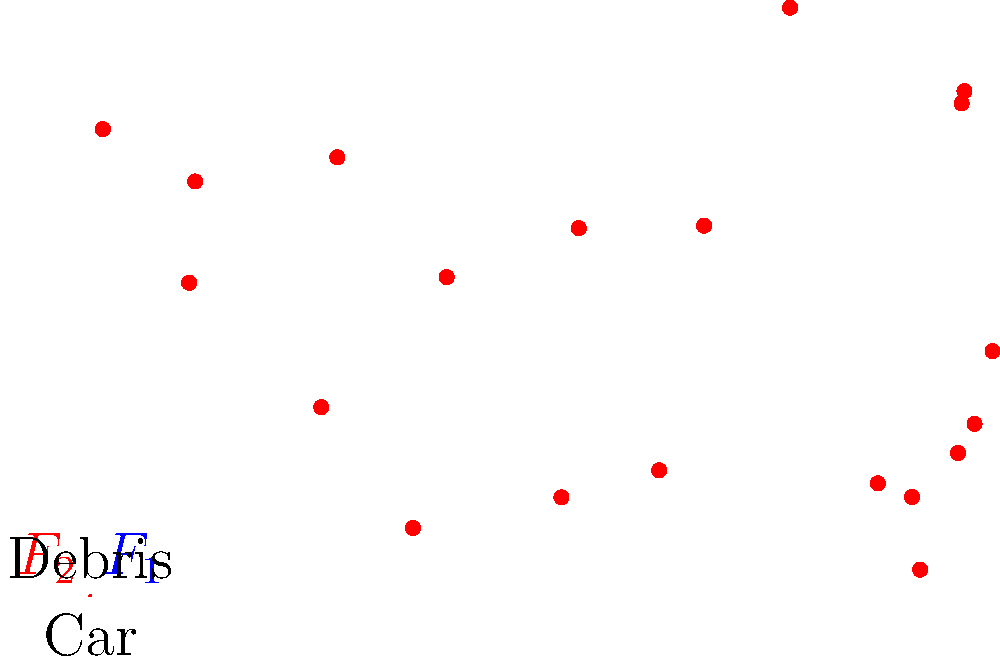In a car crash analysis, the force diagram shows two primary forces acting on the vehicle: $F_1$ at 45° to the right and upward, and $F_2$ at 135° to the left and upward. If $F_1 = 10,000$ N and $F_2 = 8,000$ N, calculate the net force acting on the car in the horizontal direction. How might this force affect the debris scatter pattern? To solve this problem, we'll follow these steps:

1. Decompose the forces into their horizontal components:
   $F_{1x} = F_1 \cos 45° = 10,000 \cdot \frac{\sqrt{2}}{2} = 7,071$ N (to the right)
   $F_{2x} = F_2 \cos 135° = 8,000 \cdot (-\frac{\sqrt{2}}{2}) = -5,657$ N (to the left)

2. Calculate the net horizontal force:
   $F_{net,x} = F_{1x} + F_{2x} = 7,071 - 5,657 = 1,414$ N (to the right)

3. Interpret the result:
   The net horizontal force of 1,414 N to the right indicates that the car will experience a resultant force pushing it towards the right side of the road.

4. Effect on debris scatter:
   The rightward net force suggests that the debris is likely to be scattered predominantly towards the right side of the crash site. This aligns with the debris pattern shown in the diagram, where most of the scattered points are to the right of the car's initial position.

5. Relevance to law and crime investigation:
   Understanding the physics of car crashes and resulting debris patterns is crucial for accident reconstruction in legal cases. This knowledge can help determine factors such as speed, impact angles, and potential causes of the crash, which are essential for both criminal investigations and civil liability cases.
Answer: 1,414 N to the right; debris likely scattered rightward 